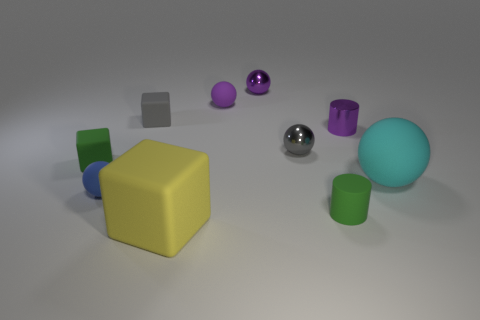There is a purple metallic cylinder that is to the right of the green object that is behind the tiny green cylinder behind the yellow matte block; what is its size?
Keep it short and to the point. Small. There is a large object that is behind the green matte cylinder; what color is it?
Offer a very short reply. Cyan. Are there more tiny metal spheres that are behind the gray block than brown matte spheres?
Provide a short and direct response. Yes. There is a green matte object that is left of the yellow object; is it the same shape as the small gray metal object?
Give a very brief answer. No. How many gray things are tiny cubes or small shiny things?
Keep it short and to the point. 2. Are there more small red matte spheres than big cyan things?
Your answer should be very brief. No. What is the color of the metallic cylinder that is the same size as the gray sphere?
Ensure brevity in your answer.  Purple. How many spheres are small shiny objects or yellow objects?
Give a very brief answer. 2. There is a large cyan thing; does it have the same shape as the gray object to the right of the purple matte object?
Offer a very short reply. Yes. How many gray blocks are the same size as the gray sphere?
Your answer should be very brief. 1. 